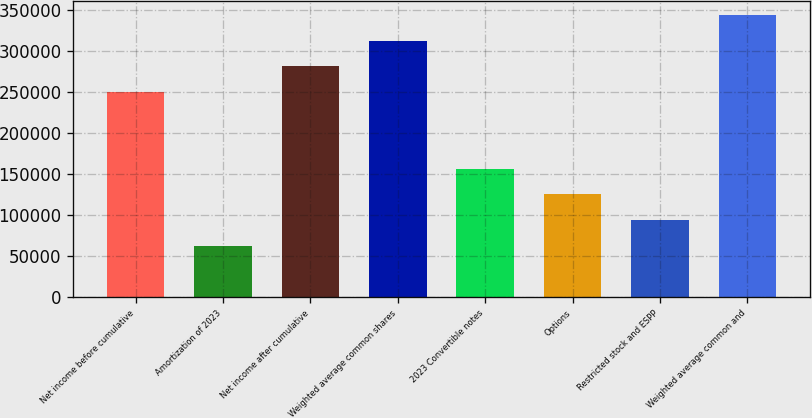Convert chart to OTSL. <chart><loc_0><loc_0><loc_500><loc_500><bar_chart><fcel>Net income before cumulative<fcel>Amortization of 2023<fcel>Net income after cumulative<fcel>Weighted average common shares<fcel>2023 Convertible notes<fcel>Options<fcel>Restricted stock and ESPP<fcel>Weighted average common and<nl><fcel>249966<fcel>62491.8<fcel>281211<fcel>312457<fcel>156229<fcel>124983<fcel>93737.5<fcel>343703<nl></chart> 